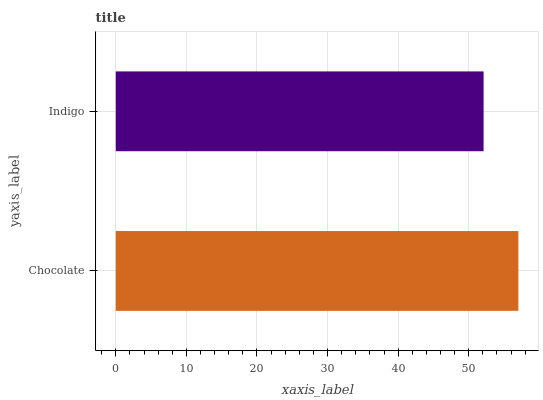Is Indigo the minimum?
Answer yes or no. Yes. Is Chocolate the maximum?
Answer yes or no. Yes. Is Indigo the maximum?
Answer yes or no. No. Is Chocolate greater than Indigo?
Answer yes or no. Yes. Is Indigo less than Chocolate?
Answer yes or no. Yes. Is Indigo greater than Chocolate?
Answer yes or no. No. Is Chocolate less than Indigo?
Answer yes or no. No. Is Chocolate the high median?
Answer yes or no. Yes. Is Indigo the low median?
Answer yes or no. Yes. Is Indigo the high median?
Answer yes or no. No. Is Chocolate the low median?
Answer yes or no. No. 